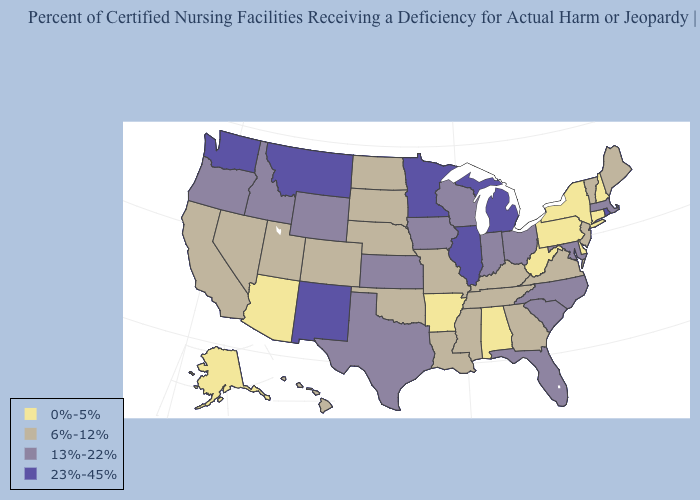Name the states that have a value in the range 6%-12%?
Answer briefly. California, Colorado, Georgia, Hawaii, Kentucky, Louisiana, Maine, Mississippi, Missouri, Nebraska, Nevada, New Jersey, North Dakota, Oklahoma, South Dakota, Tennessee, Utah, Vermont, Virginia. Does Alaska have the lowest value in the USA?
Keep it brief. Yes. Does the map have missing data?
Write a very short answer. No. Name the states that have a value in the range 23%-45%?
Answer briefly. Illinois, Michigan, Minnesota, Montana, New Mexico, Rhode Island, Washington. Is the legend a continuous bar?
Be succinct. No. What is the value of Connecticut?
Quick response, please. 0%-5%. Does Wyoming have a higher value than New York?
Quick response, please. Yes. Name the states that have a value in the range 0%-5%?
Concise answer only. Alabama, Alaska, Arizona, Arkansas, Connecticut, Delaware, New Hampshire, New York, Pennsylvania, West Virginia. Does Hawaii have the same value as New Mexico?
Keep it brief. No. How many symbols are there in the legend?
Quick response, please. 4. Does Texas have the highest value in the USA?
Short answer required. No. What is the value of New Mexico?
Short answer required. 23%-45%. Name the states that have a value in the range 0%-5%?
Write a very short answer. Alabama, Alaska, Arizona, Arkansas, Connecticut, Delaware, New Hampshire, New York, Pennsylvania, West Virginia. What is the highest value in the USA?
Short answer required. 23%-45%. What is the highest value in the USA?
Quick response, please. 23%-45%. 